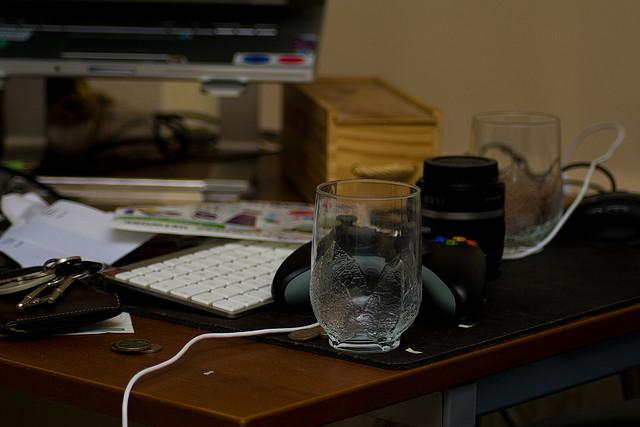What are most keys made of?

Choices:
A) copper
B) plastic
C) tin
D) steel/brass/iron steel/brass/iron 